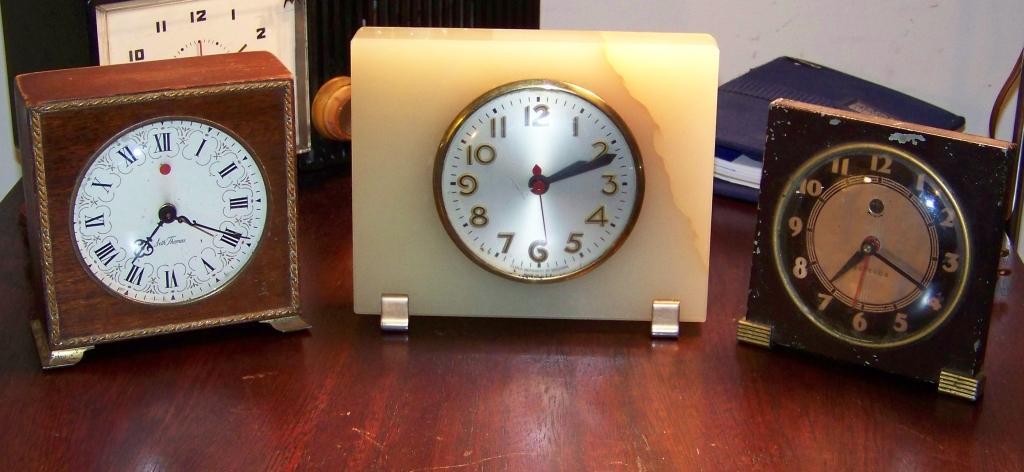Please provide a concise description of this image. In this picture there are different types of clocks and there are objects on the table. At the back it looks like a wall. Inside the clocks there are numbers and there are hours, minutes and seconds hands. 